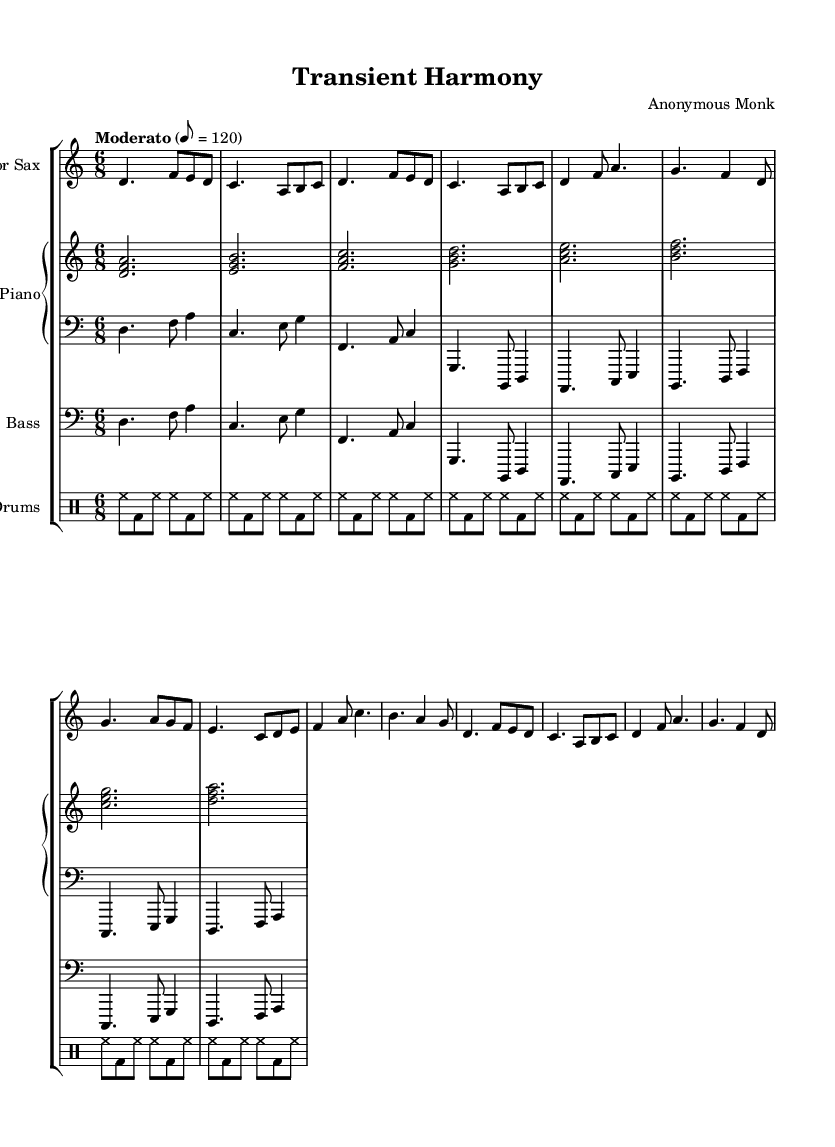What is the time signature of this music? The time signature shown in the sheet music is 6/8, indicated in the global settings. This means there are six eighth notes per measure.
Answer: 6/8 What is the key signature of this music? The key signature is D Dorian, as indicated in the global settings. D Dorian consists of the notes D, E, F, G, A, B, and C, which gives it a minor feel with a raised sixth.
Answer: D Dorian What is the tempo marking in this piece? The tempo marking indicates a speed of Moderato at 8 beats per minute set to 120. This conveys a moderate pace for the performance.
Answer: Moderato 8 = 120 How many measures are there in the A section? The A section consists of 4 measures as repeated, indicated by its first appearance, which includes phrases that clearly define the section.
Answer: 4 Which instrument plays the bass part? The bass part is indicated in the score by a clef labeled “Bass.” The instrument typically referred to here is the upright bass or electric bass guitar.
Answer: Bass What harmonic concept does this piece explore? The piece explores the concept of modal harmony with a focus on D Dorian, which allows for improvisation and variation. This aligns with Jazz's broader theme of exploring modal structures.
Answer: Modal harmony What is the role of the drums in this piece? The role of the drums is to provide rhythmic support, maintaining a consistent backbeat and complementing the other instruments with a steady pulse throughout the piece.
Answer: Rhythmic support 